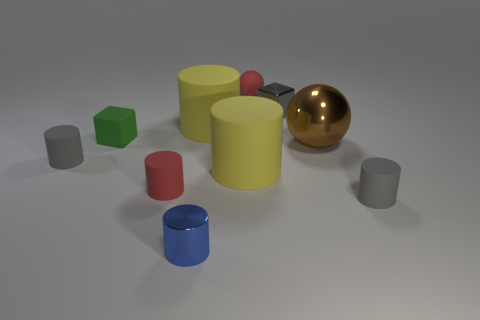Subtract 3 cylinders. How many cylinders are left? 3 Subtract all yellow cylinders. How many cylinders are left? 4 Subtract all gray cylinders. How many cylinders are left? 4 Subtract all cyan blocks. Subtract all cyan spheres. How many blocks are left? 2 Subtract all spheres. How many objects are left? 8 Add 5 small red spheres. How many small red spheres exist? 6 Subtract 0 purple cylinders. How many objects are left? 10 Subtract all tiny blue matte balls. Subtract all tiny red matte balls. How many objects are left? 9 Add 3 tiny rubber cubes. How many tiny rubber cubes are left? 4 